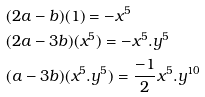<formula> <loc_0><loc_0><loc_500><loc_500>& ( 2 a - b ) ( 1 ) = - x ^ { 5 } \\ & ( 2 a - 3 b ) ( x ^ { 5 } ) = - x ^ { 5 } . y ^ { 5 } \\ & ( a - 3 b ) ( x ^ { 5 } . y ^ { 5 } ) = \frac { - 1 } { 2 } x ^ { 5 } . y ^ { 1 0 }</formula> 